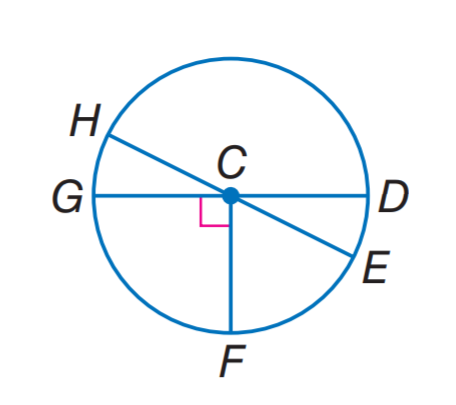Answer the mathemtical geometry problem and directly provide the correct option letter.
Question: In \odot C, m \angle H C G = 2 x and m \angle H C D = 6 x + 28, find m \widehat H D.
Choices: A: 128 B: 134 C: 142 D: 166 C 